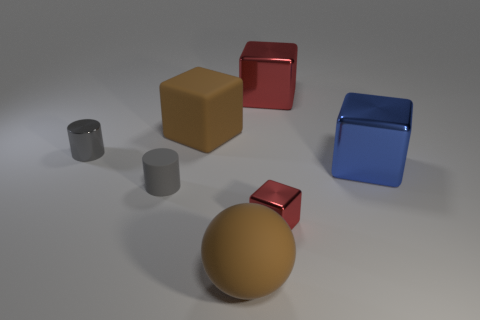Subtract all matte cubes. How many cubes are left? 3 Add 1 large cubes. How many objects exist? 8 Subtract all blue cubes. How many cubes are left? 3 Subtract all cylinders. How many objects are left? 5 Subtract all gray blocks. Subtract all purple cylinders. How many blocks are left? 4 Subtract all green balls. How many red cubes are left? 2 Subtract all red metal blocks. Subtract all brown matte cubes. How many objects are left? 4 Add 5 big brown spheres. How many big brown spheres are left? 6 Add 2 brown rubber spheres. How many brown rubber spheres exist? 3 Subtract 1 brown spheres. How many objects are left? 6 